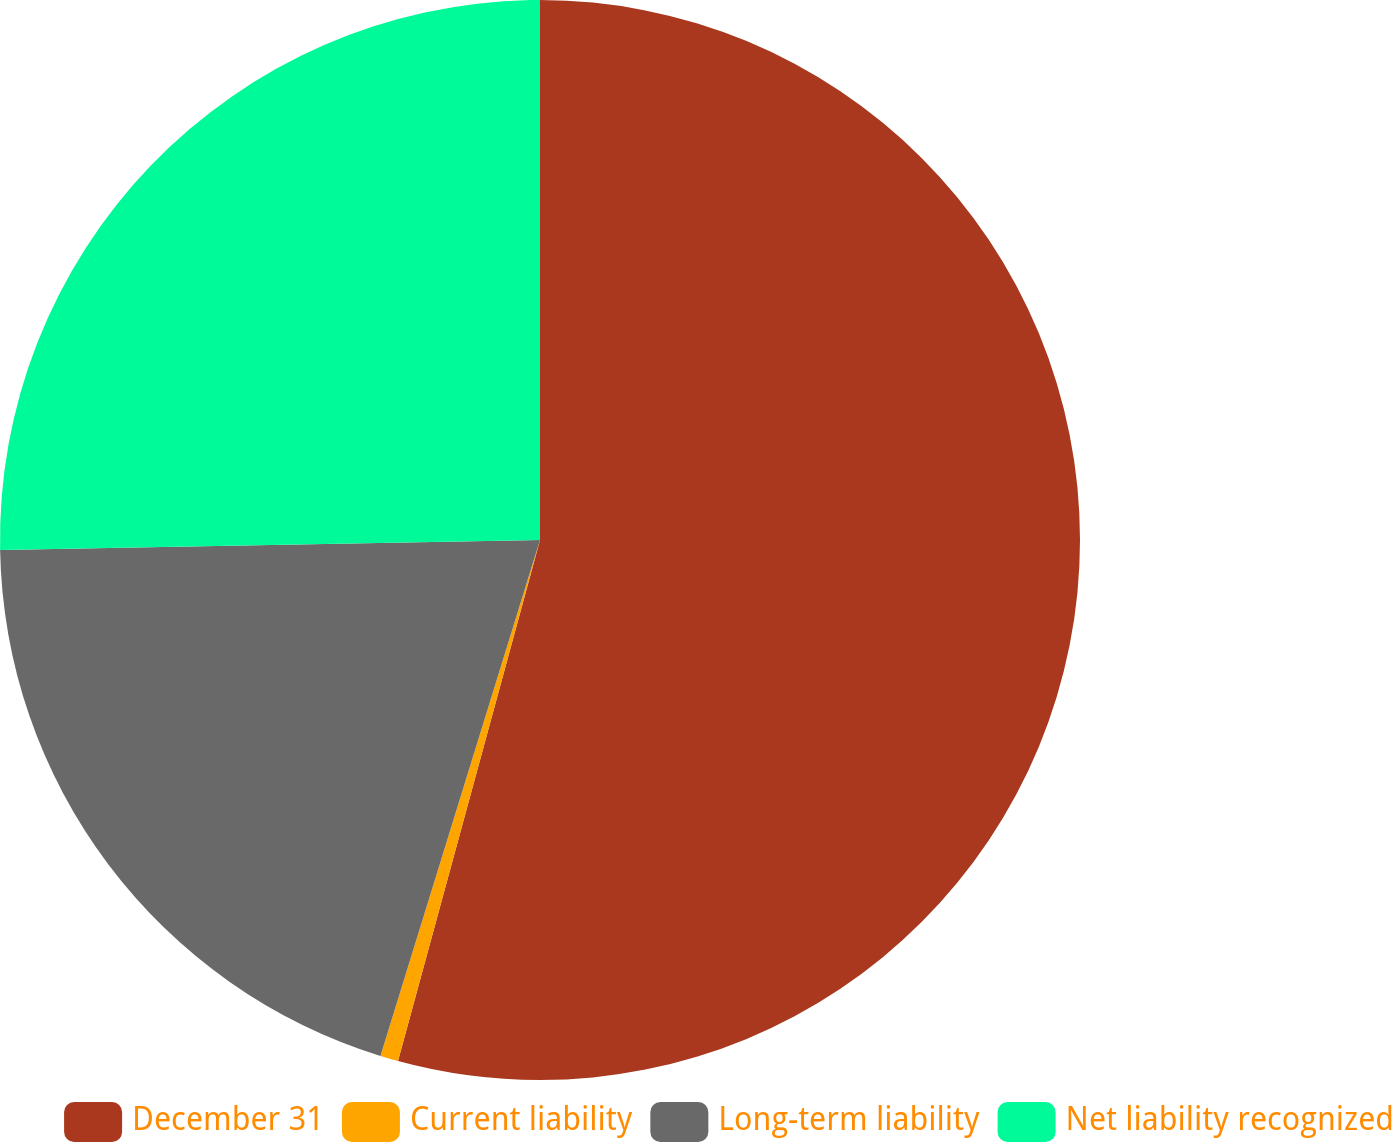Convert chart. <chart><loc_0><loc_0><loc_500><loc_500><pie_chart><fcel>December 31<fcel>Current liability<fcel>Long-term liability<fcel>Net liability recognized<nl><fcel>54.24%<fcel>0.54%<fcel>19.93%<fcel>25.3%<nl></chart> 